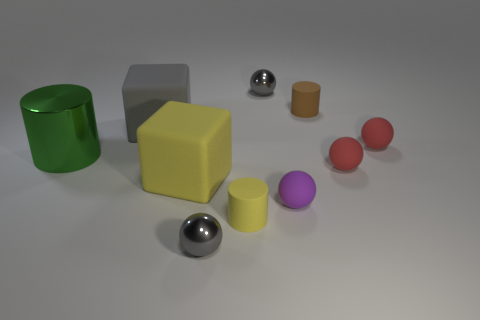Does the gray metal ball that is behind the green cylinder have the same size as the gray cube? No, the gray metal ball positioned behind the green cylinder is smaller in diameter compared to the edge length of the gray cube. 